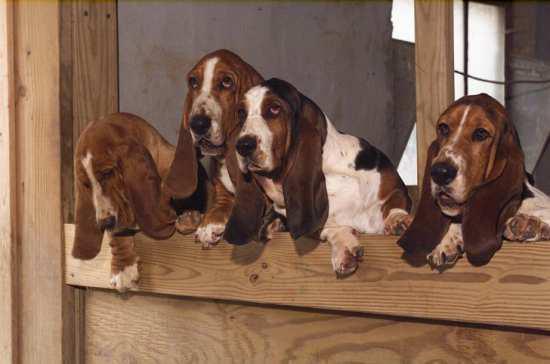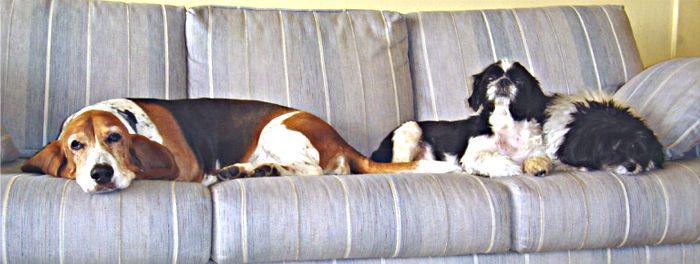The first image is the image on the left, the second image is the image on the right. Given the left and right images, does the statement "At least one dog is resting on a couch." hold true? Answer yes or no. Yes. The first image is the image on the left, the second image is the image on the right. For the images displayed, is the sentence "Four long eared beagles are looking over a wooden barrier." factually correct? Answer yes or no. Yes. 